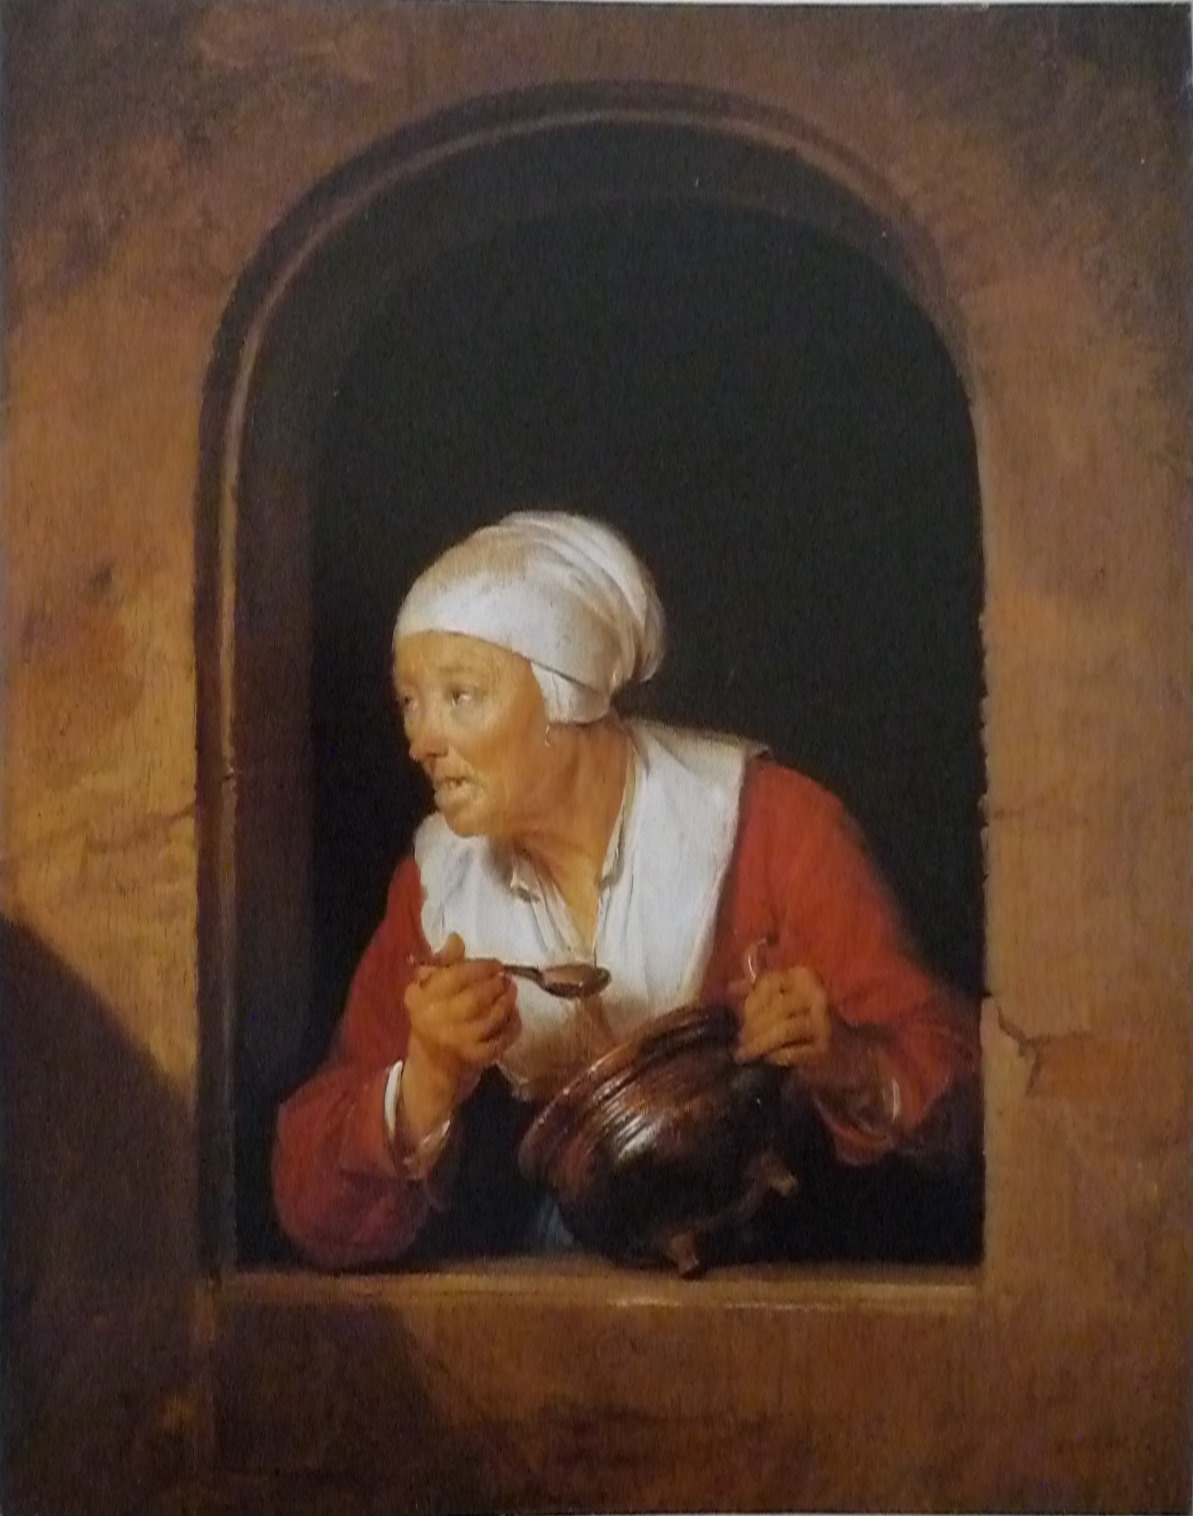Write a detailed description of the given image.
 The image is a captivating representation of an elderly woman, painted in the distinctive Baroque style that was prevalent in the 17th century. The woman, adorned in a vibrant red blouse, leans out of a window, her face etched with an expression of surprise. A white headscarf, possibly indicative of her age or status, is wrapped around her head, contrasting with the warm tones of her blouse. In her hands, she holds a brown jug, adding a rustic touch to the scene. The artist's skillful use of color and light brings a sense of depth and realism to the painting, characteristic of the Baroque period. The detailed depiction of the woman and her surroundings provides a glimpse into the life and times of the era. 